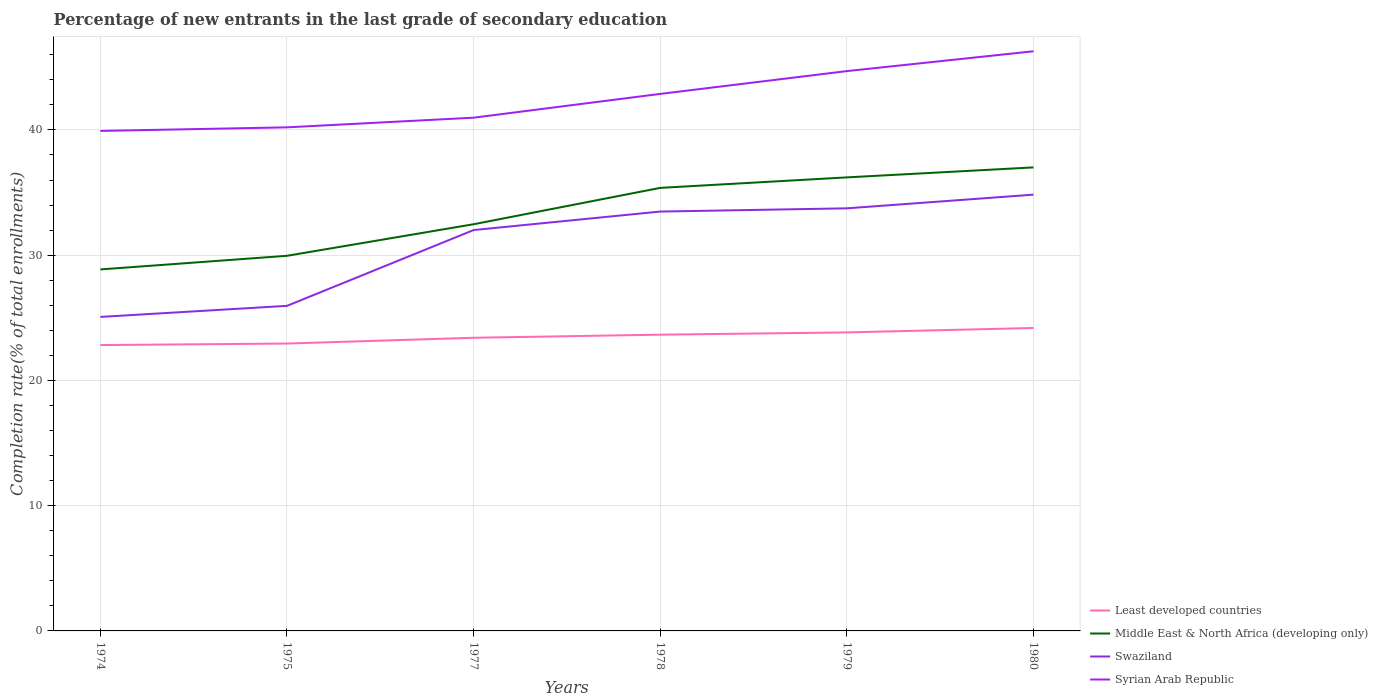Across all years, what is the maximum percentage of new entrants in Middle East & North Africa (developing only)?
Your answer should be very brief. 28.86. In which year was the percentage of new entrants in Syrian Arab Republic maximum?
Make the answer very short. 1974. What is the total percentage of new entrants in Least developed countries in the graph?
Offer a very short reply. -1.01. What is the difference between the highest and the second highest percentage of new entrants in Syrian Arab Republic?
Keep it short and to the point. 6.36. What is the difference between the highest and the lowest percentage of new entrants in Syrian Arab Republic?
Your answer should be compact. 3. Is the percentage of new entrants in Swaziland strictly greater than the percentage of new entrants in Syrian Arab Republic over the years?
Provide a succinct answer. Yes. What is the difference between two consecutive major ticks on the Y-axis?
Make the answer very short. 10. Does the graph contain any zero values?
Provide a succinct answer. No. Does the graph contain grids?
Your response must be concise. Yes. Where does the legend appear in the graph?
Offer a very short reply. Bottom right. How are the legend labels stacked?
Provide a succinct answer. Vertical. What is the title of the graph?
Provide a succinct answer. Percentage of new entrants in the last grade of secondary education. Does "Libya" appear as one of the legend labels in the graph?
Ensure brevity in your answer.  No. What is the label or title of the Y-axis?
Offer a terse response. Completion rate(% of total enrollments). What is the Completion rate(% of total enrollments) of Least developed countries in 1974?
Offer a terse response. 22.82. What is the Completion rate(% of total enrollments) in Middle East & North Africa (developing only) in 1974?
Ensure brevity in your answer.  28.86. What is the Completion rate(% of total enrollments) of Swaziland in 1974?
Provide a succinct answer. 25.07. What is the Completion rate(% of total enrollments) in Syrian Arab Republic in 1974?
Offer a very short reply. 39.92. What is the Completion rate(% of total enrollments) of Least developed countries in 1975?
Make the answer very short. 22.94. What is the Completion rate(% of total enrollments) of Middle East & North Africa (developing only) in 1975?
Give a very brief answer. 29.95. What is the Completion rate(% of total enrollments) in Swaziland in 1975?
Keep it short and to the point. 25.95. What is the Completion rate(% of total enrollments) of Syrian Arab Republic in 1975?
Provide a succinct answer. 40.21. What is the Completion rate(% of total enrollments) in Least developed countries in 1977?
Keep it short and to the point. 23.41. What is the Completion rate(% of total enrollments) of Middle East & North Africa (developing only) in 1977?
Give a very brief answer. 32.47. What is the Completion rate(% of total enrollments) in Swaziland in 1977?
Your response must be concise. 32.01. What is the Completion rate(% of total enrollments) of Syrian Arab Republic in 1977?
Give a very brief answer. 40.98. What is the Completion rate(% of total enrollments) of Least developed countries in 1978?
Your answer should be compact. 23.65. What is the Completion rate(% of total enrollments) of Middle East & North Africa (developing only) in 1978?
Your answer should be compact. 35.38. What is the Completion rate(% of total enrollments) in Swaziland in 1978?
Offer a terse response. 33.48. What is the Completion rate(% of total enrollments) of Syrian Arab Republic in 1978?
Make the answer very short. 42.88. What is the Completion rate(% of total enrollments) in Least developed countries in 1979?
Offer a very short reply. 23.83. What is the Completion rate(% of total enrollments) of Middle East & North Africa (developing only) in 1979?
Keep it short and to the point. 36.21. What is the Completion rate(% of total enrollments) in Swaziland in 1979?
Your answer should be very brief. 33.74. What is the Completion rate(% of total enrollments) of Syrian Arab Republic in 1979?
Keep it short and to the point. 44.7. What is the Completion rate(% of total enrollments) of Least developed countries in 1980?
Your response must be concise. 24.19. What is the Completion rate(% of total enrollments) of Middle East & North Africa (developing only) in 1980?
Ensure brevity in your answer.  37.01. What is the Completion rate(% of total enrollments) in Swaziland in 1980?
Your response must be concise. 34.83. What is the Completion rate(% of total enrollments) of Syrian Arab Republic in 1980?
Offer a very short reply. 46.28. Across all years, what is the maximum Completion rate(% of total enrollments) in Least developed countries?
Give a very brief answer. 24.19. Across all years, what is the maximum Completion rate(% of total enrollments) of Middle East & North Africa (developing only)?
Your answer should be very brief. 37.01. Across all years, what is the maximum Completion rate(% of total enrollments) in Swaziland?
Ensure brevity in your answer.  34.83. Across all years, what is the maximum Completion rate(% of total enrollments) of Syrian Arab Republic?
Provide a short and direct response. 46.28. Across all years, what is the minimum Completion rate(% of total enrollments) in Least developed countries?
Ensure brevity in your answer.  22.82. Across all years, what is the minimum Completion rate(% of total enrollments) in Middle East & North Africa (developing only)?
Your answer should be compact. 28.86. Across all years, what is the minimum Completion rate(% of total enrollments) of Swaziland?
Offer a very short reply. 25.07. Across all years, what is the minimum Completion rate(% of total enrollments) of Syrian Arab Republic?
Offer a terse response. 39.92. What is the total Completion rate(% of total enrollments) in Least developed countries in the graph?
Your answer should be very brief. 140.85. What is the total Completion rate(% of total enrollments) in Middle East & North Africa (developing only) in the graph?
Offer a very short reply. 199.89. What is the total Completion rate(% of total enrollments) of Swaziland in the graph?
Give a very brief answer. 185.09. What is the total Completion rate(% of total enrollments) in Syrian Arab Republic in the graph?
Your answer should be very brief. 254.97. What is the difference between the Completion rate(% of total enrollments) of Least developed countries in 1974 and that in 1975?
Provide a succinct answer. -0.12. What is the difference between the Completion rate(% of total enrollments) in Middle East & North Africa (developing only) in 1974 and that in 1975?
Provide a succinct answer. -1.09. What is the difference between the Completion rate(% of total enrollments) in Swaziland in 1974 and that in 1975?
Your response must be concise. -0.88. What is the difference between the Completion rate(% of total enrollments) in Syrian Arab Republic in 1974 and that in 1975?
Your answer should be compact. -0.29. What is the difference between the Completion rate(% of total enrollments) in Least developed countries in 1974 and that in 1977?
Keep it short and to the point. -0.58. What is the difference between the Completion rate(% of total enrollments) in Middle East & North Africa (developing only) in 1974 and that in 1977?
Make the answer very short. -3.61. What is the difference between the Completion rate(% of total enrollments) of Swaziland in 1974 and that in 1977?
Keep it short and to the point. -6.94. What is the difference between the Completion rate(% of total enrollments) in Syrian Arab Republic in 1974 and that in 1977?
Your answer should be compact. -1.06. What is the difference between the Completion rate(% of total enrollments) of Least developed countries in 1974 and that in 1978?
Make the answer very short. -0.83. What is the difference between the Completion rate(% of total enrollments) in Middle East & North Africa (developing only) in 1974 and that in 1978?
Offer a terse response. -6.51. What is the difference between the Completion rate(% of total enrollments) in Swaziland in 1974 and that in 1978?
Provide a short and direct response. -8.41. What is the difference between the Completion rate(% of total enrollments) of Syrian Arab Republic in 1974 and that in 1978?
Provide a short and direct response. -2.96. What is the difference between the Completion rate(% of total enrollments) of Least developed countries in 1974 and that in 1979?
Provide a succinct answer. -1.01. What is the difference between the Completion rate(% of total enrollments) of Middle East & North Africa (developing only) in 1974 and that in 1979?
Your response must be concise. -7.35. What is the difference between the Completion rate(% of total enrollments) of Swaziland in 1974 and that in 1979?
Give a very brief answer. -8.67. What is the difference between the Completion rate(% of total enrollments) in Syrian Arab Republic in 1974 and that in 1979?
Keep it short and to the point. -4.78. What is the difference between the Completion rate(% of total enrollments) of Least developed countries in 1974 and that in 1980?
Your answer should be compact. -1.36. What is the difference between the Completion rate(% of total enrollments) of Middle East & North Africa (developing only) in 1974 and that in 1980?
Give a very brief answer. -8.15. What is the difference between the Completion rate(% of total enrollments) of Swaziland in 1974 and that in 1980?
Keep it short and to the point. -9.76. What is the difference between the Completion rate(% of total enrollments) in Syrian Arab Republic in 1974 and that in 1980?
Give a very brief answer. -6.36. What is the difference between the Completion rate(% of total enrollments) in Least developed countries in 1975 and that in 1977?
Your answer should be compact. -0.46. What is the difference between the Completion rate(% of total enrollments) of Middle East & North Africa (developing only) in 1975 and that in 1977?
Your answer should be compact. -2.52. What is the difference between the Completion rate(% of total enrollments) in Swaziland in 1975 and that in 1977?
Provide a succinct answer. -6.05. What is the difference between the Completion rate(% of total enrollments) in Syrian Arab Republic in 1975 and that in 1977?
Keep it short and to the point. -0.77. What is the difference between the Completion rate(% of total enrollments) in Least developed countries in 1975 and that in 1978?
Offer a terse response. -0.71. What is the difference between the Completion rate(% of total enrollments) in Middle East & North Africa (developing only) in 1975 and that in 1978?
Your response must be concise. -5.42. What is the difference between the Completion rate(% of total enrollments) in Swaziland in 1975 and that in 1978?
Your answer should be compact. -7.53. What is the difference between the Completion rate(% of total enrollments) of Syrian Arab Republic in 1975 and that in 1978?
Keep it short and to the point. -2.67. What is the difference between the Completion rate(% of total enrollments) of Least developed countries in 1975 and that in 1979?
Your answer should be compact. -0.89. What is the difference between the Completion rate(% of total enrollments) of Middle East & North Africa (developing only) in 1975 and that in 1979?
Your answer should be very brief. -6.26. What is the difference between the Completion rate(% of total enrollments) of Swaziland in 1975 and that in 1979?
Provide a succinct answer. -7.79. What is the difference between the Completion rate(% of total enrollments) of Syrian Arab Republic in 1975 and that in 1979?
Keep it short and to the point. -4.49. What is the difference between the Completion rate(% of total enrollments) of Least developed countries in 1975 and that in 1980?
Offer a very short reply. -1.24. What is the difference between the Completion rate(% of total enrollments) in Middle East & North Africa (developing only) in 1975 and that in 1980?
Your response must be concise. -7.06. What is the difference between the Completion rate(% of total enrollments) in Swaziland in 1975 and that in 1980?
Keep it short and to the point. -8.88. What is the difference between the Completion rate(% of total enrollments) in Syrian Arab Republic in 1975 and that in 1980?
Give a very brief answer. -6.07. What is the difference between the Completion rate(% of total enrollments) of Least developed countries in 1977 and that in 1978?
Make the answer very short. -0.25. What is the difference between the Completion rate(% of total enrollments) in Middle East & North Africa (developing only) in 1977 and that in 1978?
Offer a terse response. -2.9. What is the difference between the Completion rate(% of total enrollments) in Swaziland in 1977 and that in 1978?
Give a very brief answer. -1.48. What is the difference between the Completion rate(% of total enrollments) of Syrian Arab Republic in 1977 and that in 1978?
Offer a very short reply. -1.9. What is the difference between the Completion rate(% of total enrollments) in Least developed countries in 1977 and that in 1979?
Your response must be concise. -0.43. What is the difference between the Completion rate(% of total enrollments) in Middle East & North Africa (developing only) in 1977 and that in 1979?
Your response must be concise. -3.74. What is the difference between the Completion rate(% of total enrollments) of Swaziland in 1977 and that in 1979?
Offer a very short reply. -1.73. What is the difference between the Completion rate(% of total enrollments) of Syrian Arab Republic in 1977 and that in 1979?
Your answer should be very brief. -3.72. What is the difference between the Completion rate(% of total enrollments) in Least developed countries in 1977 and that in 1980?
Offer a very short reply. -0.78. What is the difference between the Completion rate(% of total enrollments) of Middle East & North Africa (developing only) in 1977 and that in 1980?
Provide a succinct answer. -4.54. What is the difference between the Completion rate(% of total enrollments) in Swaziland in 1977 and that in 1980?
Offer a terse response. -2.83. What is the difference between the Completion rate(% of total enrollments) of Syrian Arab Republic in 1977 and that in 1980?
Give a very brief answer. -5.3. What is the difference between the Completion rate(% of total enrollments) in Least developed countries in 1978 and that in 1979?
Offer a very short reply. -0.18. What is the difference between the Completion rate(% of total enrollments) in Middle East & North Africa (developing only) in 1978 and that in 1979?
Provide a short and direct response. -0.84. What is the difference between the Completion rate(% of total enrollments) in Swaziland in 1978 and that in 1979?
Provide a short and direct response. -0.26. What is the difference between the Completion rate(% of total enrollments) in Syrian Arab Republic in 1978 and that in 1979?
Provide a short and direct response. -1.82. What is the difference between the Completion rate(% of total enrollments) of Least developed countries in 1978 and that in 1980?
Offer a terse response. -0.53. What is the difference between the Completion rate(% of total enrollments) in Middle East & North Africa (developing only) in 1978 and that in 1980?
Keep it short and to the point. -1.63. What is the difference between the Completion rate(% of total enrollments) of Swaziland in 1978 and that in 1980?
Ensure brevity in your answer.  -1.35. What is the difference between the Completion rate(% of total enrollments) of Syrian Arab Republic in 1978 and that in 1980?
Keep it short and to the point. -3.4. What is the difference between the Completion rate(% of total enrollments) in Least developed countries in 1979 and that in 1980?
Provide a short and direct response. -0.35. What is the difference between the Completion rate(% of total enrollments) of Middle East & North Africa (developing only) in 1979 and that in 1980?
Your answer should be compact. -0.8. What is the difference between the Completion rate(% of total enrollments) of Swaziland in 1979 and that in 1980?
Give a very brief answer. -1.09. What is the difference between the Completion rate(% of total enrollments) of Syrian Arab Republic in 1979 and that in 1980?
Ensure brevity in your answer.  -1.58. What is the difference between the Completion rate(% of total enrollments) of Least developed countries in 1974 and the Completion rate(% of total enrollments) of Middle East & North Africa (developing only) in 1975?
Your answer should be very brief. -7.13. What is the difference between the Completion rate(% of total enrollments) of Least developed countries in 1974 and the Completion rate(% of total enrollments) of Swaziland in 1975?
Keep it short and to the point. -3.13. What is the difference between the Completion rate(% of total enrollments) of Least developed countries in 1974 and the Completion rate(% of total enrollments) of Syrian Arab Republic in 1975?
Ensure brevity in your answer.  -17.38. What is the difference between the Completion rate(% of total enrollments) of Middle East & North Africa (developing only) in 1974 and the Completion rate(% of total enrollments) of Swaziland in 1975?
Your answer should be very brief. 2.91. What is the difference between the Completion rate(% of total enrollments) of Middle East & North Africa (developing only) in 1974 and the Completion rate(% of total enrollments) of Syrian Arab Republic in 1975?
Offer a terse response. -11.34. What is the difference between the Completion rate(% of total enrollments) of Swaziland in 1974 and the Completion rate(% of total enrollments) of Syrian Arab Republic in 1975?
Provide a short and direct response. -15.14. What is the difference between the Completion rate(% of total enrollments) in Least developed countries in 1974 and the Completion rate(% of total enrollments) in Middle East & North Africa (developing only) in 1977?
Offer a very short reply. -9.65. What is the difference between the Completion rate(% of total enrollments) of Least developed countries in 1974 and the Completion rate(% of total enrollments) of Swaziland in 1977?
Provide a short and direct response. -9.18. What is the difference between the Completion rate(% of total enrollments) of Least developed countries in 1974 and the Completion rate(% of total enrollments) of Syrian Arab Republic in 1977?
Provide a succinct answer. -18.15. What is the difference between the Completion rate(% of total enrollments) of Middle East & North Africa (developing only) in 1974 and the Completion rate(% of total enrollments) of Swaziland in 1977?
Make the answer very short. -3.14. What is the difference between the Completion rate(% of total enrollments) in Middle East & North Africa (developing only) in 1974 and the Completion rate(% of total enrollments) in Syrian Arab Republic in 1977?
Offer a terse response. -12.12. What is the difference between the Completion rate(% of total enrollments) in Swaziland in 1974 and the Completion rate(% of total enrollments) in Syrian Arab Republic in 1977?
Your response must be concise. -15.91. What is the difference between the Completion rate(% of total enrollments) in Least developed countries in 1974 and the Completion rate(% of total enrollments) in Middle East & North Africa (developing only) in 1978?
Your response must be concise. -12.55. What is the difference between the Completion rate(% of total enrollments) in Least developed countries in 1974 and the Completion rate(% of total enrollments) in Swaziland in 1978?
Provide a succinct answer. -10.66. What is the difference between the Completion rate(% of total enrollments) of Least developed countries in 1974 and the Completion rate(% of total enrollments) of Syrian Arab Republic in 1978?
Give a very brief answer. -20.05. What is the difference between the Completion rate(% of total enrollments) of Middle East & North Africa (developing only) in 1974 and the Completion rate(% of total enrollments) of Swaziland in 1978?
Your answer should be compact. -4.62. What is the difference between the Completion rate(% of total enrollments) in Middle East & North Africa (developing only) in 1974 and the Completion rate(% of total enrollments) in Syrian Arab Republic in 1978?
Keep it short and to the point. -14.02. What is the difference between the Completion rate(% of total enrollments) in Swaziland in 1974 and the Completion rate(% of total enrollments) in Syrian Arab Republic in 1978?
Offer a terse response. -17.81. What is the difference between the Completion rate(% of total enrollments) in Least developed countries in 1974 and the Completion rate(% of total enrollments) in Middle East & North Africa (developing only) in 1979?
Offer a terse response. -13.39. What is the difference between the Completion rate(% of total enrollments) of Least developed countries in 1974 and the Completion rate(% of total enrollments) of Swaziland in 1979?
Provide a short and direct response. -10.92. What is the difference between the Completion rate(% of total enrollments) in Least developed countries in 1974 and the Completion rate(% of total enrollments) in Syrian Arab Republic in 1979?
Your response must be concise. -21.87. What is the difference between the Completion rate(% of total enrollments) of Middle East & North Africa (developing only) in 1974 and the Completion rate(% of total enrollments) of Swaziland in 1979?
Provide a succinct answer. -4.88. What is the difference between the Completion rate(% of total enrollments) of Middle East & North Africa (developing only) in 1974 and the Completion rate(% of total enrollments) of Syrian Arab Republic in 1979?
Offer a terse response. -15.83. What is the difference between the Completion rate(% of total enrollments) in Swaziland in 1974 and the Completion rate(% of total enrollments) in Syrian Arab Republic in 1979?
Your response must be concise. -19.63. What is the difference between the Completion rate(% of total enrollments) of Least developed countries in 1974 and the Completion rate(% of total enrollments) of Middle East & North Africa (developing only) in 1980?
Provide a short and direct response. -14.19. What is the difference between the Completion rate(% of total enrollments) of Least developed countries in 1974 and the Completion rate(% of total enrollments) of Swaziland in 1980?
Provide a succinct answer. -12.01. What is the difference between the Completion rate(% of total enrollments) of Least developed countries in 1974 and the Completion rate(% of total enrollments) of Syrian Arab Republic in 1980?
Provide a short and direct response. -23.46. What is the difference between the Completion rate(% of total enrollments) in Middle East & North Africa (developing only) in 1974 and the Completion rate(% of total enrollments) in Swaziland in 1980?
Keep it short and to the point. -5.97. What is the difference between the Completion rate(% of total enrollments) of Middle East & North Africa (developing only) in 1974 and the Completion rate(% of total enrollments) of Syrian Arab Republic in 1980?
Provide a succinct answer. -17.42. What is the difference between the Completion rate(% of total enrollments) in Swaziland in 1974 and the Completion rate(% of total enrollments) in Syrian Arab Republic in 1980?
Keep it short and to the point. -21.21. What is the difference between the Completion rate(% of total enrollments) of Least developed countries in 1975 and the Completion rate(% of total enrollments) of Middle East & North Africa (developing only) in 1977?
Ensure brevity in your answer.  -9.53. What is the difference between the Completion rate(% of total enrollments) of Least developed countries in 1975 and the Completion rate(% of total enrollments) of Swaziland in 1977?
Offer a very short reply. -9.06. What is the difference between the Completion rate(% of total enrollments) in Least developed countries in 1975 and the Completion rate(% of total enrollments) in Syrian Arab Republic in 1977?
Keep it short and to the point. -18.03. What is the difference between the Completion rate(% of total enrollments) of Middle East & North Africa (developing only) in 1975 and the Completion rate(% of total enrollments) of Swaziland in 1977?
Make the answer very short. -2.06. What is the difference between the Completion rate(% of total enrollments) in Middle East & North Africa (developing only) in 1975 and the Completion rate(% of total enrollments) in Syrian Arab Republic in 1977?
Ensure brevity in your answer.  -11.03. What is the difference between the Completion rate(% of total enrollments) in Swaziland in 1975 and the Completion rate(% of total enrollments) in Syrian Arab Republic in 1977?
Keep it short and to the point. -15.02. What is the difference between the Completion rate(% of total enrollments) in Least developed countries in 1975 and the Completion rate(% of total enrollments) in Middle East & North Africa (developing only) in 1978?
Ensure brevity in your answer.  -12.43. What is the difference between the Completion rate(% of total enrollments) of Least developed countries in 1975 and the Completion rate(% of total enrollments) of Swaziland in 1978?
Ensure brevity in your answer.  -10.54. What is the difference between the Completion rate(% of total enrollments) of Least developed countries in 1975 and the Completion rate(% of total enrollments) of Syrian Arab Republic in 1978?
Ensure brevity in your answer.  -19.93. What is the difference between the Completion rate(% of total enrollments) in Middle East & North Africa (developing only) in 1975 and the Completion rate(% of total enrollments) in Swaziland in 1978?
Your answer should be compact. -3.53. What is the difference between the Completion rate(% of total enrollments) in Middle East & North Africa (developing only) in 1975 and the Completion rate(% of total enrollments) in Syrian Arab Republic in 1978?
Keep it short and to the point. -12.93. What is the difference between the Completion rate(% of total enrollments) of Swaziland in 1975 and the Completion rate(% of total enrollments) of Syrian Arab Republic in 1978?
Your answer should be compact. -16.92. What is the difference between the Completion rate(% of total enrollments) of Least developed countries in 1975 and the Completion rate(% of total enrollments) of Middle East & North Africa (developing only) in 1979?
Keep it short and to the point. -13.27. What is the difference between the Completion rate(% of total enrollments) in Least developed countries in 1975 and the Completion rate(% of total enrollments) in Swaziland in 1979?
Offer a very short reply. -10.8. What is the difference between the Completion rate(% of total enrollments) of Least developed countries in 1975 and the Completion rate(% of total enrollments) of Syrian Arab Republic in 1979?
Offer a very short reply. -21.75. What is the difference between the Completion rate(% of total enrollments) in Middle East & North Africa (developing only) in 1975 and the Completion rate(% of total enrollments) in Swaziland in 1979?
Make the answer very short. -3.79. What is the difference between the Completion rate(% of total enrollments) in Middle East & North Africa (developing only) in 1975 and the Completion rate(% of total enrollments) in Syrian Arab Republic in 1979?
Provide a succinct answer. -14.75. What is the difference between the Completion rate(% of total enrollments) in Swaziland in 1975 and the Completion rate(% of total enrollments) in Syrian Arab Republic in 1979?
Offer a terse response. -18.74. What is the difference between the Completion rate(% of total enrollments) of Least developed countries in 1975 and the Completion rate(% of total enrollments) of Middle East & North Africa (developing only) in 1980?
Provide a succinct answer. -14.07. What is the difference between the Completion rate(% of total enrollments) of Least developed countries in 1975 and the Completion rate(% of total enrollments) of Swaziland in 1980?
Provide a short and direct response. -11.89. What is the difference between the Completion rate(% of total enrollments) in Least developed countries in 1975 and the Completion rate(% of total enrollments) in Syrian Arab Republic in 1980?
Keep it short and to the point. -23.34. What is the difference between the Completion rate(% of total enrollments) of Middle East & North Africa (developing only) in 1975 and the Completion rate(% of total enrollments) of Swaziland in 1980?
Your response must be concise. -4.88. What is the difference between the Completion rate(% of total enrollments) in Middle East & North Africa (developing only) in 1975 and the Completion rate(% of total enrollments) in Syrian Arab Republic in 1980?
Your response must be concise. -16.33. What is the difference between the Completion rate(% of total enrollments) in Swaziland in 1975 and the Completion rate(% of total enrollments) in Syrian Arab Republic in 1980?
Your answer should be very brief. -20.33. What is the difference between the Completion rate(% of total enrollments) of Least developed countries in 1977 and the Completion rate(% of total enrollments) of Middle East & North Africa (developing only) in 1978?
Keep it short and to the point. -11.97. What is the difference between the Completion rate(% of total enrollments) in Least developed countries in 1977 and the Completion rate(% of total enrollments) in Swaziland in 1978?
Your answer should be very brief. -10.08. What is the difference between the Completion rate(% of total enrollments) of Least developed countries in 1977 and the Completion rate(% of total enrollments) of Syrian Arab Republic in 1978?
Provide a succinct answer. -19.47. What is the difference between the Completion rate(% of total enrollments) in Middle East & North Africa (developing only) in 1977 and the Completion rate(% of total enrollments) in Swaziland in 1978?
Make the answer very short. -1.01. What is the difference between the Completion rate(% of total enrollments) of Middle East & North Africa (developing only) in 1977 and the Completion rate(% of total enrollments) of Syrian Arab Republic in 1978?
Your answer should be very brief. -10.41. What is the difference between the Completion rate(% of total enrollments) in Swaziland in 1977 and the Completion rate(% of total enrollments) in Syrian Arab Republic in 1978?
Provide a succinct answer. -10.87. What is the difference between the Completion rate(% of total enrollments) of Least developed countries in 1977 and the Completion rate(% of total enrollments) of Middle East & North Africa (developing only) in 1979?
Provide a short and direct response. -12.81. What is the difference between the Completion rate(% of total enrollments) of Least developed countries in 1977 and the Completion rate(% of total enrollments) of Swaziland in 1979?
Make the answer very short. -10.34. What is the difference between the Completion rate(% of total enrollments) of Least developed countries in 1977 and the Completion rate(% of total enrollments) of Syrian Arab Republic in 1979?
Your answer should be very brief. -21.29. What is the difference between the Completion rate(% of total enrollments) of Middle East & North Africa (developing only) in 1977 and the Completion rate(% of total enrollments) of Swaziland in 1979?
Ensure brevity in your answer.  -1.27. What is the difference between the Completion rate(% of total enrollments) of Middle East & North Africa (developing only) in 1977 and the Completion rate(% of total enrollments) of Syrian Arab Republic in 1979?
Make the answer very short. -12.23. What is the difference between the Completion rate(% of total enrollments) of Swaziland in 1977 and the Completion rate(% of total enrollments) of Syrian Arab Republic in 1979?
Your answer should be compact. -12.69. What is the difference between the Completion rate(% of total enrollments) in Least developed countries in 1977 and the Completion rate(% of total enrollments) in Middle East & North Africa (developing only) in 1980?
Your answer should be very brief. -13.6. What is the difference between the Completion rate(% of total enrollments) of Least developed countries in 1977 and the Completion rate(% of total enrollments) of Swaziland in 1980?
Offer a very short reply. -11.43. What is the difference between the Completion rate(% of total enrollments) in Least developed countries in 1977 and the Completion rate(% of total enrollments) in Syrian Arab Republic in 1980?
Your answer should be compact. -22.88. What is the difference between the Completion rate(% of total enrollments) of Middle East & North Africa (developing only) in 1977 and the Completion rate(% of total enrollments) of Swaziland in 1980?
Offer a very short reply. -2.36. What is the difference between the Completion rate(% of total enrollments) of Middle East & North Africa (developing only) in 1977 and the Completion rate(% of total enrollments) of Syrian Arab Republic in 1980?
Provide a succinct answer. -13.81. What is the difference between the Completion rate(% of total enrollments) in Swaziland in 1977 and the Completion rate(% of total enrollments) in Syrian Arab Republic in 1980?
Provide a succinct answer. -14.28. What is the difference between the Completion rate(% of total enrollments) of Least developed countries in 1978 and the Completion rate(% of total enrollments) of Middle East & North Africa (developing only) in 1979?
Ensure brevity in your answer.  -12.56. What is the difference between the Completion rate(% of total enrollments) of Least developed countries in 1978 and the Completion rate(% of total enrollments) of Swaziland in 1979?
Provide a succinct answer. -10.09. What is the difference between the Completion rate(% of total enrollments) in Least developed countries in 1978 and the Completion rate(% of total enrollments) in Syrian Arab Republic in 1979?
Provide a short and direct response. -21.04. What is the difference between the Completion rate(% of total enrollments) in Middle East & North Africa (developing only) in 1978 and the Completion rate(% of total enrollments) in Swaziland in 1979?
Provide a short and direct response. 1.63. What is the difference between the Completion rate(% of total enrollments) of Middle East & North Africa (developing only) in 1978 and the Completion rate(% of total enrollments) of Syrian Arab Republic in 1979?
Your response must be concise. -9.32. What is the difference between the Completion rate(% of total enrollments) of Swaziland in 1978 and the Completion rate(% of total enrollments) of Syrian Arab Republic in 1979?
Offer a very short reply. -11.21. What is the difference between the Completion rate(% of total enrollments) of Least developed countries in 1978 and the Completion rate(% of total enrollments) of Middle East & North Africa (developing only) in 1980?
Make the answer very short. -13.36. What is the difference between the Completion rate(% of total enrollments) of Least developed countries in 1978 and the Completion rate(% of total enrollments) of Swaziland in 1980?
Ensure brevity in your answer.  -11.18. What is the difference between the Completion rate(% of total enrollments) of Least developed countries in 1978 and the Completion rate(% of total enrollments) of Syrian Arab Republic in 1980?
Your answer should be very brief. -22.63. What is the difference between the Completion rate(% of total enrollments) in Middle East & North Africa (developing only) in 1978 and the Completion rate(% of total enrollments) in Swaziland in 1980?
Keep it short and to the point. 0.54. What is the difference between the Completion rate(% of total enrollments) in Middle East & North Africa (developing only) in 1978 and the Completion rate(% of total enrollments) in Syrian Arab Republic in 1980?
Give a very brief answer. -10.91. What is the difference between the Completion rate(% of total enrollments) of Swaziland in 1978 and the Completion rate(% of total enrollments) of Syrian Arab Republic in 1980?
Ensure brevity in your answer.  -12.8. What is the difference between the Completion rate(% of total enrollments) in Least developed countries in 1979 and the Completion rate(% of total enrollments) in Middle East & North Africa (developing only) in 1980?
Ensure brevity in your answer.  -13.18. What is the difference between the Completion rate(% of total enrollments) of Least developed countries in 1979 and the Completion rate(% of total enrollments) of Swaziland in 1980?
Ensure brevity in your answer.  -11. What is the difference between the Completion rate(% of total enrollments) of Least developed countries in 1979 and the Completion rate(% of total enrollments) of Syrian Arab Republic in 1980?
Offer a very short reply. -22.45. What is the difference between the Completion rate(% of total enrollments) of Middle East & North Africa (developing only) in 1979 and the Completion rate(% of total enrollments) of Swaziland in 1980?
Give a very brief answer. 1.38. What is the difference between the Completion rate(% of total enrollments) of Middle East & North Africa (developing only) in 1979 and the Completion rate(% of total enrollments) of Syrian Arab Republic in 1980?
Provide a short and direct response. -10.07. What is the difference between the Completion rate(% of total enrollments) of Swaziland in 1979 and the Completion rate(% of total enrollments) of Syrian Arab Republic in 1980?
Your response must be concise. -12.54. What is the average Completion rate(% of total enrollments) of Least developed countries per year?
Give a very brief answer. 23.48. What is the average Completion rate(% of total enrollments) of Middle East & North Africa (developing only) per year?
Your response must be concise. 33.31. What is the average Completion rate(% of total enrollments) of Swaziland per year?
Provide a short and direct response. 30.85. What is the average Completion rate(% of total enrollments) in Syrian Arab Republic per year?
Make the answer very short. 42.49. In the year 1974, what is the difference between the Completion rate(% of total enrollments) of Least developed countries and Completion rate(% of total enrollments) of Middle East & North Africa (developing only)?
Your response must be concise. -6.04. In the year 1974, what is the difference between the Completion rate(% of total enrollments) in Least developed countries and Completion rate(% of total enrollments) in Swaziland?
Offer a terse response. -2.25. In the year 1974, what is the difference between the Completion rate(% of total enrollments) of Least developed countries and Completion rate(% of total enrollments) of Syrian Arab Republic?
Ensure brevity in your answer.  -17.1. In the year 1974, what is the difference between the Completion rate(% of total enrollments) in Middle East & North Africa (developing only) and Completion rate(% of total enrollments) in Swaziland?
Your answer should be compact. 3.79. In the year 1974, what is the difference between the Completion rate(% of total enrollments) of Middle East & North Africa (developing only) and Completion rate(% of total enrollments) of Syrian Arab Republic?
Your answer should be compact. -11.06. In the year 1974, what is the difference between the Completion rate(% of total enrollments) in Swaziland and Completion rate(% of total enrollments) in Syrian Arab Republic?
Give a very brief answer. -14.85. In the year 1975, what is the difference between the Completion rate(% of total enrollments) of Least developed countries and Completion rate(% of total enrollments) of Middle East & North Africa (developing only)?
Ensure brevity in your answer.  -7.01. In the year 1975, what is the difference between the Completion rate(% of total enrollments) of Least developed countries and Completion rate(% of total enrollments) of Swaziland?
Give a very brief answer. -3.01. In the year 1975, what is the difference between the Completion rate(% of total enrollments) of Least developed countries and Completion rate(% of total enrollments) of Syrian Arab Republic?
Your answer should be very brief. -17.26. In the year 1975, what is the difference between the Completion rate(% of total enrollments) of Middle East & North Africa (developing only) and Completion rate(% of total enrollments) of Swaziland?
Offer a terse response. 4. In the year 1975, what is the difference between the Completion rate(% of total enrollments) in Middle East & North Africa (developing only) and Completion rate(% of total enrollments) in Syrian Arab Republic?
Your response must be concise. -10.26. In the year 1975, what is the difference between the Completion rate(% of total enrollments) of Swaziland and Completion rate(% of total enrollments) of Syrian Arab Republic?
Offer a very short reply. -14.25. In the year 1977, what is the difference between the Completion rate(% of total enrollments) in Least developed countries and Completion rate(% of total enrollments) in Middle East & North Africa (developing only)?
Your answer should be compact. -9.06. In the year 1977, what is the difference between the Completion rate(% of total enrollments) in Least developed countries and Completion rate(% of total enrollments) in Swaziland?
Ensure brevity in your answer.  -8.6. In the year 1977, what is the difference between the Completion rate(% of total enrollments) of Least developed countries and Completion rate(% of total enrollments) of Syrian Arab Republic?
Provide a short and direct response. -17.57. In the year 1977, what is the difference between the Completion rate(% of total enrollments) in Middle East & North Africa (developing only) and Completion rate(% of total enrollments) in Swaziland?
Ensure brevity in your answer.  0.46. In the year 1977, what is the difference between the Completion rate(% of total enrollments) in Middle East & North Africa (developing only) and Completion rate(% of total enrollments) in Syrian Arab Republic?
Offer a very short reply. -8.51. In the year 1977, what is the difference between the Completion rate(% of total enrollments) of Swaziland and Completion rate(% of total enrollments) of Syrian Arab Republic?
Your answer should be very brief. -8.97. In the year 1978, what is the difference between the Completion rate(% of total enrollments) of Least developed countries and Completion rate(% of total enrollments) of Middle East & North Africa (developing only)?
Offer a very short reply. -11.72. In the year 1978, what is the difference between the Completion rate(% of total enrollments) in Least developed countries and Completion rate(% of total enrollments) in Swaziland?
Make the answer very short. -9.83. In the year 1978, what is the difference between the Completion rate(% of total enrollments) of Least developed countries and Completion rate(% of total enrollments) of Syrian Arab Republic?
Ensure brevity in your answer.  -19.23. In the year 1978, what is the difference between the Completion rate(% of total enrollments) of Middle East & North Africa (developing only) and Completion rate(% of total enrollments) of Swaziland?
Keep it short and to the point. 1.89. In the year 1978, what is the difference between the Completion rate(% of total enrollments) in Middle East & North Africa (developing only) and Completion rate(% of total enrollments) in Syrian Arab Republic?
Provide a succinct answer. -7.5. In the year 1978, what is the difference between the Completion rate(% of total enrollments) of Swaziland and Completion rate(% of total enrollments) of Syrian Arab Republic?
Offer a terse response. -9.4. In the year 1979, what is the difference between the Completion rate(% of total enrollments) in Least developed countries and Completion rate(% of total enrollments) in Middle East & North Africa (developing only)?
Offer a very short reply. -12.38. In the year 1979, what is the difference between the Completion rate(% of total enrollments) in Least developed countries and Completion rate(% of total enrollments) in Swaziland?
Offer a terse response. -9.91. In the year 1979, what is the difference between the Completion rate(% of total enrollments) of Least developed countries and Completion rate(% of total enrollments) of Syrian Arab Republic?
Offer a very short reply. -20.86. In the year 1979, what is the difference between the Completion rate(% of total enrollments) in Middle East & North Africa (developing only) and Completion rate(% of total enrollments) in Swaziland?
Offer a very short reply. 2.47. In the year 1979, what is the difference between the Completion rate(% of total enrollments) of Middle East & North Africa (developing only) and Completion rate(% of total enrollments) of Syrian Arab Republic?
Your answer should be compact. -8.49. In the year 1979, what is the difference between the Completion rate(% of total enrollments) in Swaziland and Completion rate(% of total enrollments) in Syrian Arab Republic?
Your answer should be very brief. -10.96. In the year 1980, what is the difference between the Completion rate(% of total enrollments) in Least developed countries and Completion rate(% of total enrollments) in Middle East & North Africa (developing only)?
Offer a very short reply. -12.82. In the year 1980, what is the difference between the Completion rate(% of total enrollments) in Least developed countries and Completion rate(% of total enrollments) in Swaziland?
Give a very brief answer. -10.64. In the year 1980, what is the difference between the Completion rate(% of total enrollments) in Least developed countries and Completion rate(% of total enrollments) in Syrian Arab Republic?
Your answer should be compact. -22.09. In the year 1980, what is the difference between the Completion rate(% of total enrollments) in Middle East & North Africa (developing only) and Completion rate(% of total enrollments) in Swaziland?
Give a very brief answer. 2.18. In the year 1980, what is the difference between the Completion rate(% of total enrollments) in Middle East & North Africa (developing only) and Completion rate(% of total enrollments) in Syrian Arab Republic?
Offer a very short reply. -9.27. In the year 1980, what is the difference between the Completion rate(% of total enrollments) of Swaziland and Completion rate(% of total enrollments) of Syrian Arab Republic?
Offer a very short reply. -11.45. What is the ratio of the Completion rate(% of total enrollments) of Least developed countries in 1974 to that in 1975?
Make the answer very short. 0.99. What is the ratio of the Completion rate(% of total enrollments) of Middle East & North Africa (developing only) in 1974 to that in 1975?
Provide a succinct answer. 0.96. What is the ratio of the Completion rate(% of total enrollments) of Swaziland in 1974 to that in 1975?
Give a very brief answer. 0.97. What is the ratio of the Completion rate(% of total enrollments) of Least developed countries in 1974 to that in 1977?
Your answer should be compact. 0.98. What is the ratio of the Completion rate(% of total enrollments) of Middle East & North Africa (developing only) in 1974 to that in 1977?
Your answer should be compact. 0.89. What is the ratio of the Completion rate(% of total enrollments) in Swaziland in 1974 to that in 1977?
Make the answer very short. 0.78. What is the ratio of the Completion rate(% of total enrollments) of Syrian Arab Republic in 1974 to that in 1977?
Offer a very short reply. 0.97. What is the ratio of the Completion rate(% of total enrollments) of Least developed countries in 1974 to that in 1978?
Keep it short and to the point. 0.96. What is the ratio of the Completion rate(% of total enrollments) of Middle East & North Africa (developing only) in 1974 to that in 1978?
Offer a terse response. 0.82. What is the ratio of the Completion rate(% of total enrollments) in Swaziland in 1974 to that in 1978?
Offer a terse response. 0.75. What is the ratio of the Completion rate(% of total enrollments) of Syrian Arab Republic in 1974 to that in 1978?
Offer a very short reply. 0.93. What is the ratio of the Completion rate(% of total enrollments) in Least developed countries in 1974 to that in 1979?
Keep it short and to the point. 0.96. What is the ratio of the Completion rate(% of total enrollments) of Middle East & North Africa (developing only) in 1974 to that in 1979?
Provide a succinct answer. 0.8. What is the ratio of the Completion rate(% of total enrollments) in Swaziland in 1974 to that in 1979?
Make the answer very short. 0.74. What is the ratio of the Completion rate(% of total enrollments) of Syrian Arab Republic in 1974 to that in 1979?
Keep it short and to the point. 0.89. What is the ratio of the Completion rate(% of total enrollments) of Least developed countries in 1974 to that in 1980?
Give a very brief answer. 0.94. What is the ratio of the Completion rate(% of total enrollments) in Middle East & North Africa (developing only) in 1974 to that in 1980?
Offer a very short reply. 0.78. What is the ratio of the Completion rate(% of total enrollments) of Swaziland in 1974 to that in 1980?
Your answer should be compact. 0.72. What is the ratio of the Completion rate(% of total enrollments) in Syrian Arab Republic in 1974 to that in 1980?
Make the answer very short. 0.86. What is the ratio of the Completion rate(% of total enrollments) in Least developed countries in 1975 to that in 1977?
Your answer should be very brief. 0.98. What is the ratio of the Completion rate(% of total enrollments) in Middle East & North Africa (developing only) in 1975 to that in 1977?
Offer a terse response. 0.92. What is the ratio of the Completion rate(% of total enrollments) of Swaziland in 1975 to that in 1977?
Offer a terse response. 0.81. What is the ratio of the Completion rate(% of total enrollments) in Syrian Arab Republic in 1975 to that in 1977?
Ensure brevity in your answer.  0.98. What is the ratio of the Completion rate(% of total enrollments) of Least developed countries in 1975 to that in 1978?
Your answer should be compact. 0.97. What is the ratio of the Completion rate(% of total enrollments) of Middle East & North Africa (developing only) in 1975 to that in 1978?
Offer a terse response. 0.85. What is the ratio of the Completion rate(% of total enrollments) in Swaziland in 1975 to that in 1978?
Your response must be concise. 0.78. What is the ratio of the Completion rate(% of total enrollments) of Syrian Arab Republic in 1975 to that in 1978?
Make the answer very short. 0.94. What is the ratio of the Completion rate(% of total enrollments) in Least developed countries in 1975 to that in 1979?
Offer a very short reply. 0.96. What is the ratio of the Completion rate(% of total enrollments) in Middle East & North Africa (developing only) in 1975 to that in 1979?
Provide a short and direct response. 0.83. What is the ratio of the Completion rate(% of total enrollments) of Swaziland in 1975 to that in 1979?
Ensure brevity in your answer.  0.77. What is the ratio of the Completion rate(% of total enrollments) in Syrian Arab Republic in 1975 to that in 1979?
Give a very brief answer. 0.9. What is the ratio of the Completion rate(% of total enrollments) in Least developed countries in 1975 to that in 1980?
Make the answer very short. 0.95. What is the ratio of the Completion rate(% of total enrollments) in Middle East & North Africa (developing only) in 1975 to that in 1980?
Your response must be concise. 0.81. What is the ratio of the Completion rate(% of total enrollments) in Swaziland in 1975 to that in 1980?
Make the answer very short. 0.75. What is the ratio of the Completion rate(% of total enrollments) of Syrian Arab Republic in 1975 to that in 1980?
Offer a terse response. 0.87. What is the ratio of the Completion rate(% of total enrollments) in Least developed countries in 1977 to that in 1978?
Provide a short and direct response. 0.99. What is the ratio of the Completion rate(% of total enrollments) of Middle East & North Africa (developing only) in 1977 to that in 1978?
Offer a very short reply. 0.92. What is the ratio of the Completion rate(% of total enrollments) in Swaziland in 1977 to that in 1978?
Ensure brevity in your answer.  0.96. What is the ratio of the Completion rate(% of total enrollments) of Syrian Arab Republic in 1977 to that in 1978?
Provide a short and direct response. 0.96. What is the ratio of the Completion rate(% of total enrollments) of Least developed countries in 1977 to that in 1979?
Give a very brief answer. 0.98. What is the ratio of the Completion rate(% of total enrollments) of Middle East & North Africa (developing only) in 1977 to that in 1979?
Provide a short and direct response. 0.9. What is the ratio of the Completion rate(% of total enrollments) of Swaziland in 1977 to that in 1979?
Ensure brevity in your answer.  0.95. What is the ratio of the Completion rate(% of total enrollments) of Syrian Arab Republic in 1977 to that in 1979?
Give a very brief answer. 0.92. What is the ratio of the Completion rate(% of total enrollments) in Least developed countries in 1977 to that in 1980?
Provide a succinct answer. 0.97. What is the ratio of the Completion rate(% of total enrollments) in Middle East & North Africa (developing only) in 1977 to that in 1980?
Make the answer very short. 0.88. What is the ratio of the Completion rate(% of total enrollments) of Swaziland in 1977 to that in 1980?
Your answer should be very brief. 0.92. What is the ratio of the Completion rate(% of total enrollments) in Syrian Arab Republic in 1977 to that in 1980?
Keep it short and to the point. 0.89. What is the ratio of the Completion rate(% of total enrollments) of Middle East & North Africa (developing only) in 1978 to that in 1979?
Your answer should be very brief. 0.98. What is the ratio of the Completion rate(% of total enrollments) in Syrian Arab Republic in 1978 to that in 1979?
Keep it short and to the point. 0.96. What is the ratio of the Completion rate(% of total enrollments) in Least developed countries in 1978 to that in 1980?
Keep it short and to the point. 0.98. What is the ratio of the Completion rate(% of total enrollments) of Middle East & North Africa (developing only) in 1978 to that in 1980?
Make the answer very short. 0.96. What is the ratio of the Completion rate(% of total enrollments) of Swaziland in 1978 to that in 1980?
Give a very brief answer. 0.96. What is the ratio of the Completion rate(% of total enrollments) of Syrian Arab Republic in 1978 to that in 1980?
Make the answer very short. 0.93. What is the ratio of the Completion rate(% of total enrollments) in Least developed countries in 1979 to that in 1980?
Your response must be concise. 0.99. What is the ratio of the Completion rate(% of total enrollments) in Middle East & North Africa (developing only) in 1979 to that in 1980?
Ensure brevity in your answer.  0.98. What is the ratio of the Completion rate(% of total enrollments) of Swaziland in 1979 to that in 1980?
Provide a short and direct response. 0.97. What is the ratio of the Completion rate(% of total enrollments) in Syrian Arab Republic in 1979 to that in 1980?
Provide a succinct answer. 0.97. What is the difference between the highest and the second highest Completion rate(% of total enrollments) in Least developed countries?
Offer a very short reply. 0.35. What is the difference between the highest and the second highest Completion rate(% of total enrollments) in Middle East & North Africa (developing only)?
Provide a short and direct response. 0.8. What is the difference between the highest and the second highest Completion rate(% of total enrollments) in Swaziland?
Provide a short and direct response. 1.09. What is the difference between the highest and the second highest Completion rate(% of total enrollments) of Syrian Arab Republic?
Ensure brevity in your answer.  1.58. What is the difference between the highest and the lowest Completion rate(% of total enrollments) of Least developed countries?
Your response must be concise. 1.36. What is the difference between the highest and the lowest Completion rate(% of total enrollments) in Middle East & North Africa (developing only)?
Offer a very short reply. 8.15. What is the difference between the highest and the lowest Completion rate(% of total enrollments) of Swaziland?
Offer a very short reply. 9.76. What is the difference between the highest and the lowest Completion rate(% of total enrollments) in Syrian Arab Republic?
Keep it short and to the point. 6.36. 